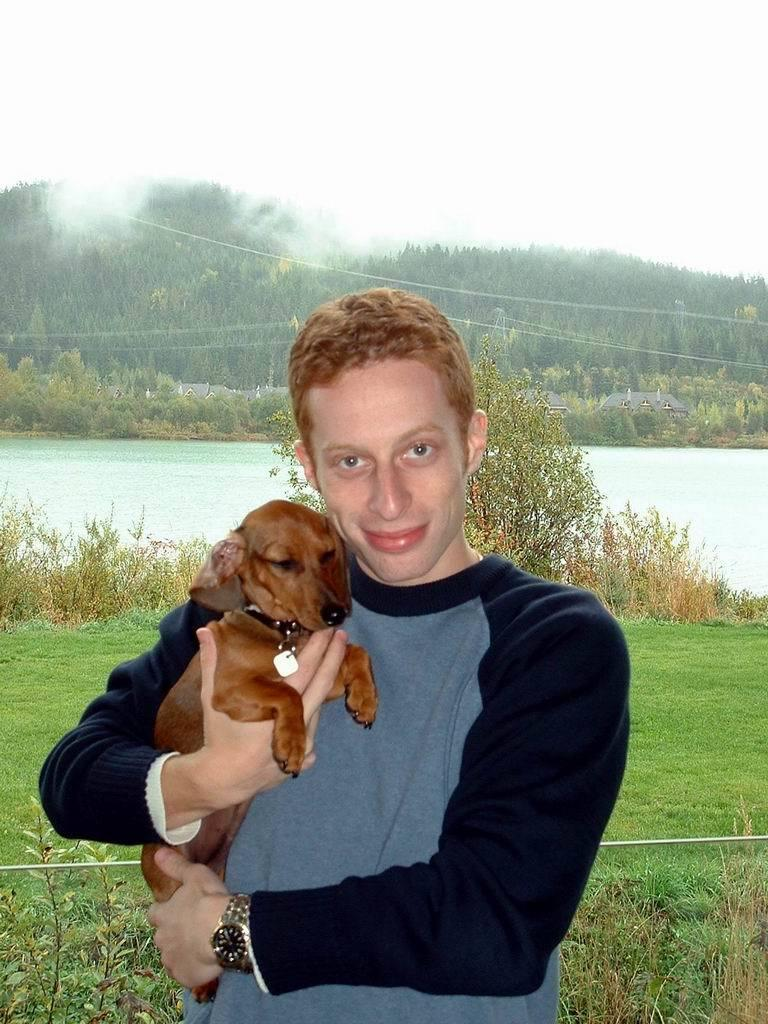What is the man in the image holding? The man is holding a dog in the image. What can be seen in the background of the image? There are trees, water, grass, and plants visible in the background of the image. What type of spark can be seen coming from the dog's collar in the image? There is no spark visible in the image, nor is there any indication that the dog's collar is emitting a spark. 